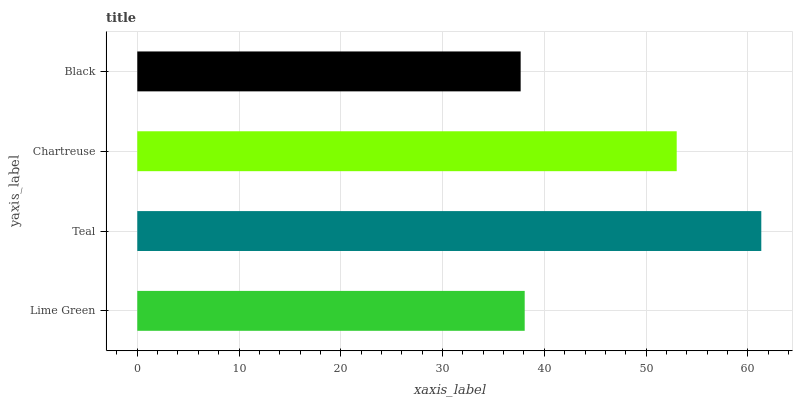Is Black the minimum?
Answer yes or no. Yes. Is Teal the maximum?
Answer yes or no. Yes. Is Chartreuse the minimum?
Answer yes or no. No. Is Chartreuse the maximum?
Answer yes or no. No. Is Teal greater than Chartreuse?
Answer yes or no. Yes. Is Chartreuse less than Teal?
Answer yes or no. Yes. Is Chartreuse greater than Teal?
Answer yes or no. No. Is Teal less than Chartreuse?
Answer yes or no. No. Is Chartreuse the high median?
Answer yes or no. Yes. Is Lime Green the low median?
Answer yes or no. Yes. Is Lime Green the high median?
Answer yes or no. No. Is Teal the low median?
Answer yes or no. No. 